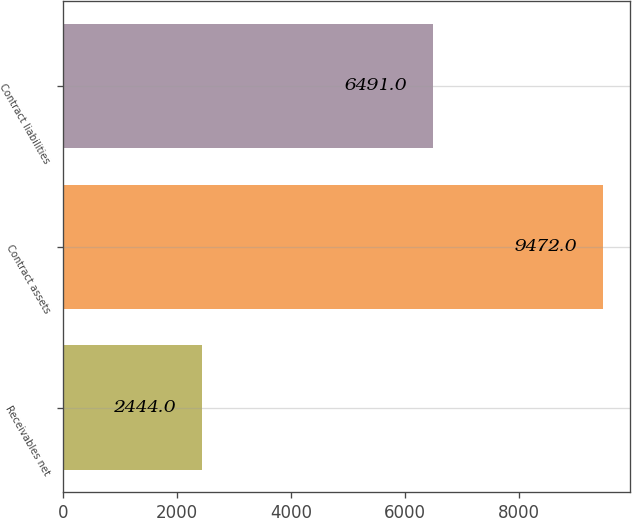<chart> <loc_0><loc_0><loc_500><loc_500><bar_chart><fcel>Receivables net<fcel>Contract assets<fcel>Contract liabilities<nl><fcel>2444<fcel>9472<fcel>6491<nl></chart> 